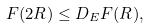Convert formula to latex. <formula><loc_0><loc_0><loc_500><loc_500>F ( 2 R ) \leq D _ { E } F ( R ) ,</formula> 